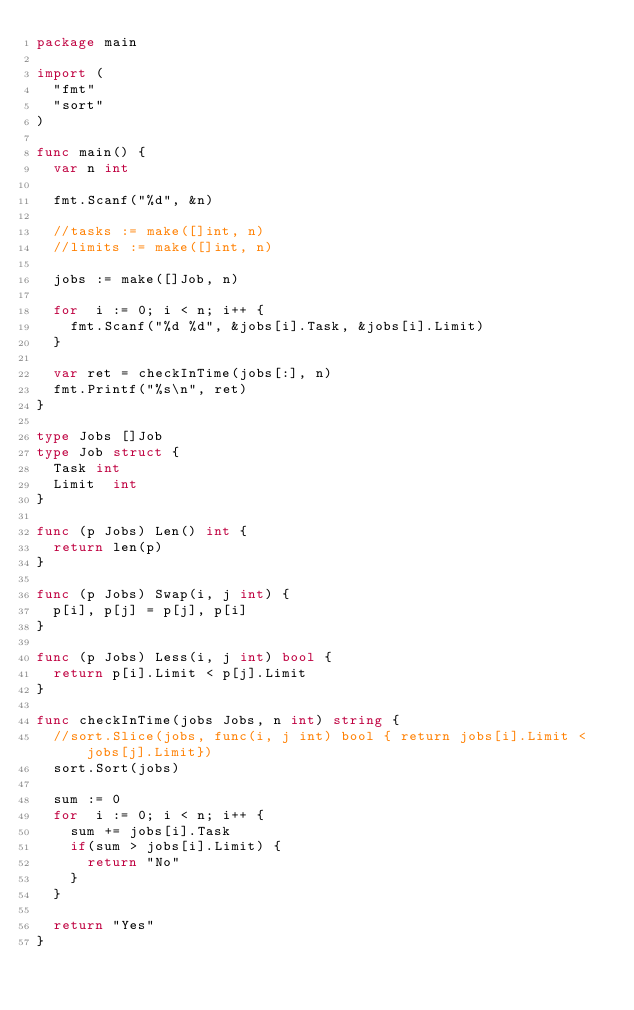<code> <loc_0><loc_0><loc_500><loc_500><_Go_>package main

import (
	"fmt"
	"sort"
)

func main() {
	var n int

	fmt.Scanf("%d", &n)

	//tasks := make([]int, n)
	//limits := make([]int, n)

	jobs := make([]Job, n)

	for  i := 0; i < n; i++ {
		fmt.Scanf("%d %d", &jobs[i].Task, &jobs[i].Limit)
	}

	var ret = checkInTime(jobs[:], n)
	fmt.Printf("%s\n", ret)
}

type Jobs []Job
type Job struct {
	Task int
	Limit  int
}

func (p Jobs) Len() int {
	return len(p)
}

func (p Jobs) Swap(i, j int) {
	p[i], p[j] = p[j], p[i]
}

func (p Jobs) Less(i, j int) bool {
	return p[i].Limit < p[j].Limit
}

func checkInTime(jobs Jobs, n int) string {
	//sort.Slice(jobs, func(i, j int) bool { return jobs[i].Limit < jobs[j].Limit})
	sort.Sort(jobs)

	sum := 0
	for  i := 0; i < n; i++ {
		sum += jobs[i].Task
		if(sum > jobs[i].Limit) {
			return "No"
		}
	}

	return "Yes"
}
</code> 